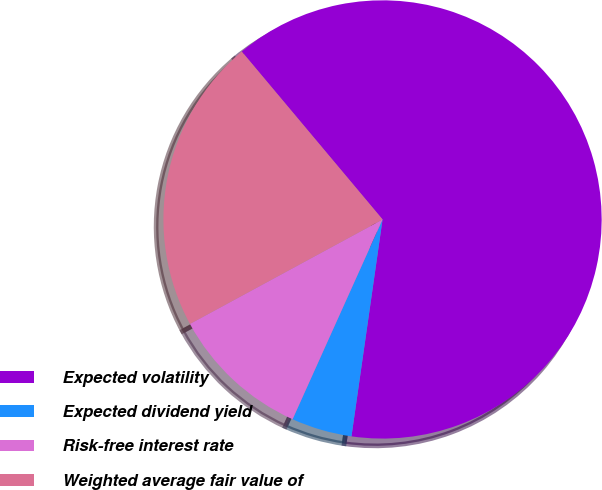Convert chart to OTSL. <chart><loc_0><loc_0><loc_500><loc_500><pie_chart><fcel>Expected volatility<fcel>Expected dividend yield<fcel>Risk-free interest rate<fcel>Weighted average fair value of<nl><fcel>63.37%<fcel>4.47%<fcel>10.36%<fcel>21.8%<nl></chart> 